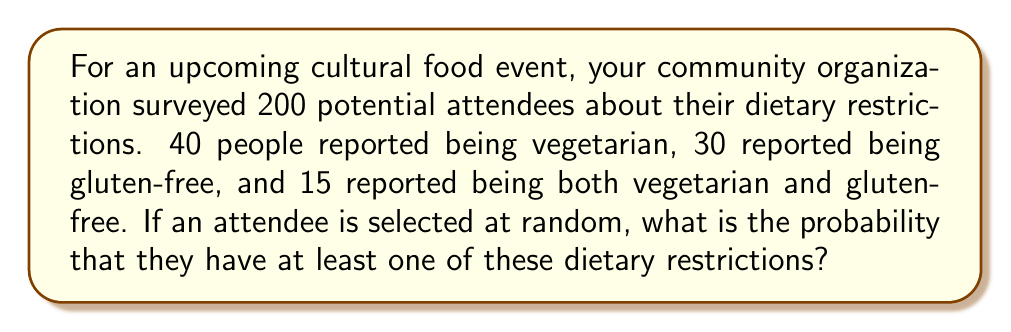Can you solve this math problem? Let's approach this step-by-step using the concept of sets and probability:

1) Let V be the set of vegetarians and G be the set of gluten-free individuals.

2) We know:
   $|V| = 40$ (number of vegetarians)
   $|G| = 30$ (number of gluten-free)
   $|V \cap G| = 15$ (number of both vegetarian and gluten-free)

3) We need to find $P(V \cup G)$, the probability of being in either set V or G or both.

4) We can use the formula: $P(V \cup G) = P(V) + P(G) - P(V \cap G)$

5) Calculate each probability:
   $P(V) = \frac{40}{200} = \frac{1}{5} = 0.2$
   $P(G) = \frac{30}{200} = \frac{3}{20} = 0.15$
   $P(V \cap G) = \frac{15}{200} = \frac{3}{40} = 0.075$

6) Now, let's substitute these values into our formula:

   $$P(V \cup G) = 0.2 + 0.15 - 0.075 = 0.275$$

7) Therefore, the probability of an attendee having at least one of these dietary restrictions is 0.275 or 27.5%.
Answer: 0.275 